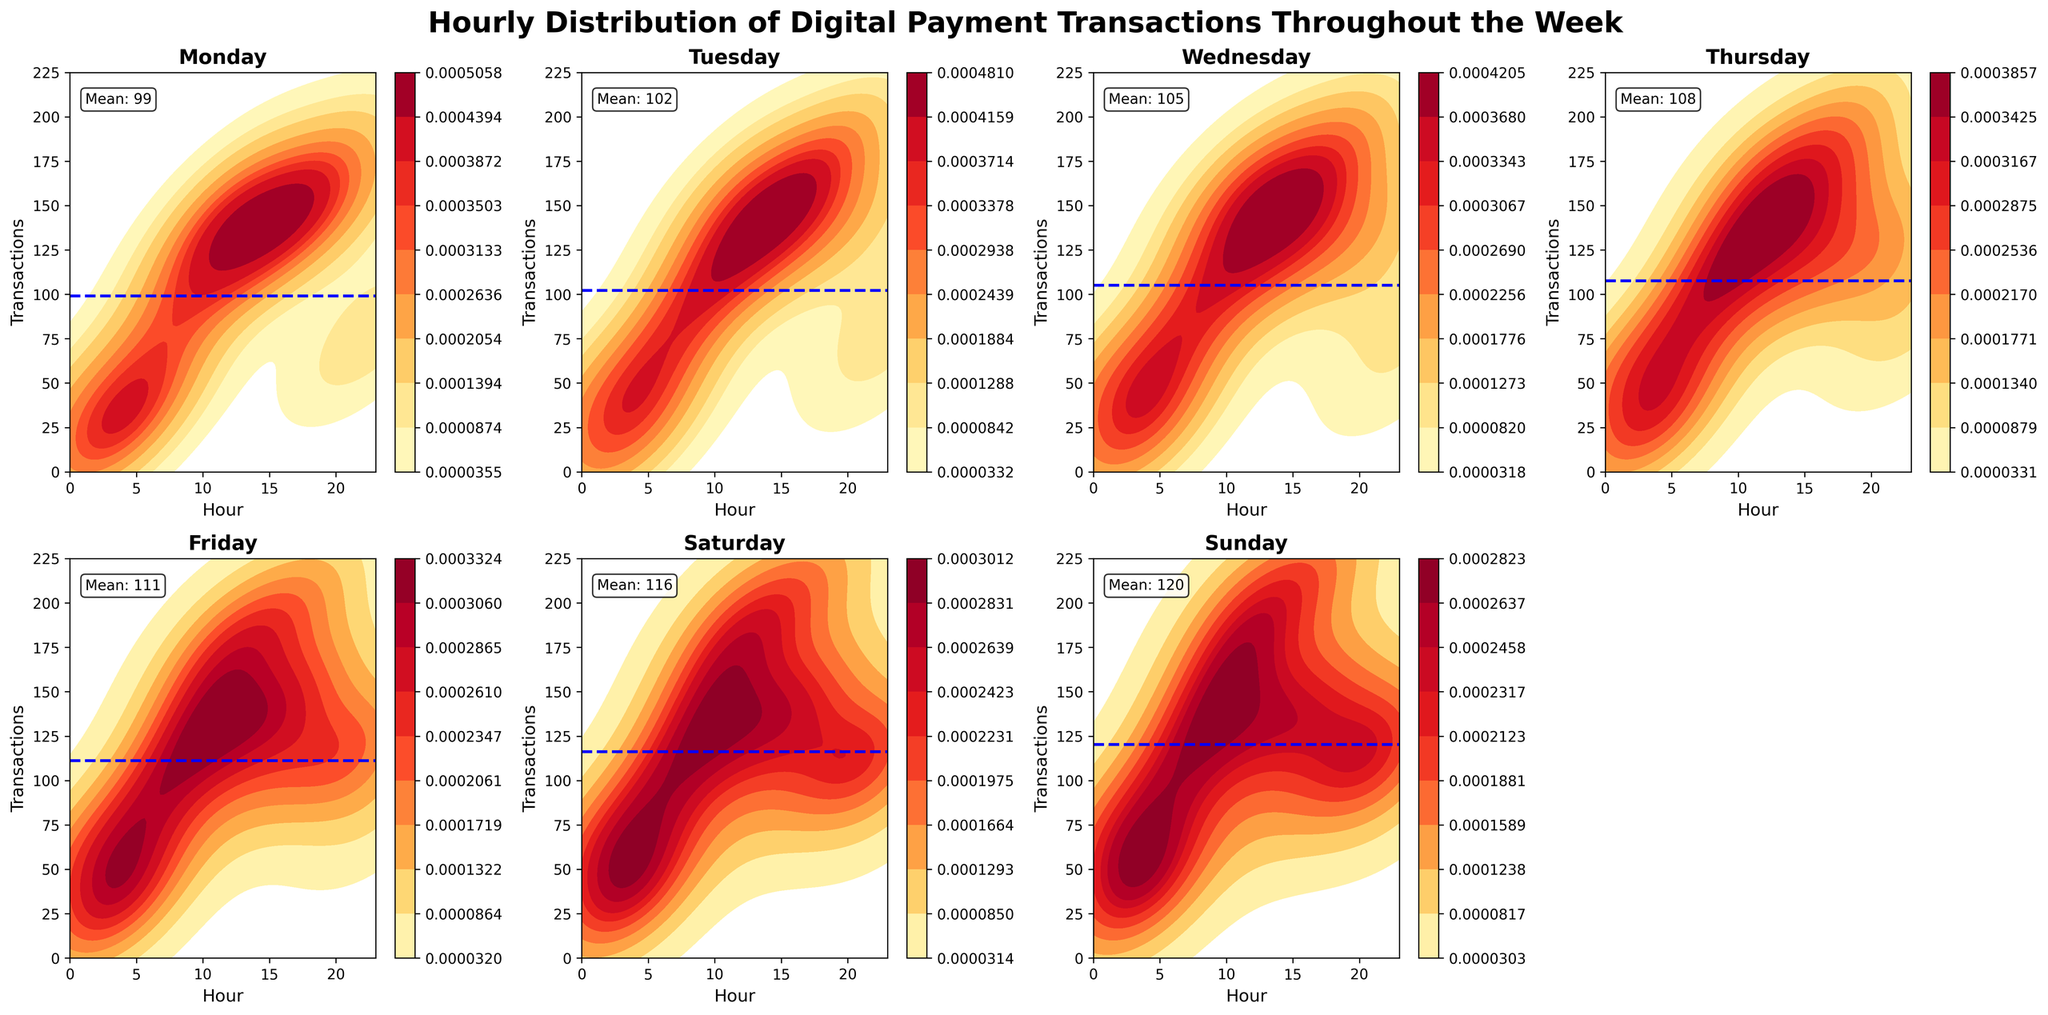What's the maximum number of transactions on Monday? Examine the Monday subplot and identify the highest value on the Transactions axis. This peak corresponds to the highest number of transactions.
Answer: 170 What is the overall trend of transactions from Monday to Sunday? Observing the density plots from Monday to Sunday, we notice that the frequency of high transaction counts generally increases towards the weekend, hitting peaks on Friday and Saturday.
Answer: Increasing On which day is the variance in transactions the highest? To determine the day with the highest variance, note the spread and concentration of density in the subplots. Days with more spread out, diverse height of the density plot lines have higher variance. Saturday and Sunday show the highest density peaks and distribution.
Answer: Saturday How does the mean number of transactions on Wednesday compare to Friday? Locate the horizontal mean line for both Wednesday and Friday. Compare their positions on the Transactions axis. The mean on Wednesday is around 108 while on Friday, it's closer to 114.
Answer: Higher on Friday Which day has the most frequent high transaction counts during the later hours (17:00-23:00)? Focus on the density distribution in each subplot during hours 17:00 to 23:00. Friday and Saturday show prominent density in this range, indicating more frequent high transaction counts.
Answer: Saturday What time of day generally has the lowest transaction counts across all days? Review each subplot and find the time span with the lowest density across all subplots. The early morning hours, around 3:00 to 5:00, show consistently low transaction densities.
Answer: 03:00-05:00 Compare the transaction pattern on Mondays and Sundays. How do they differ? Compare the subplots for Monday and Sunday. While both have lower transaction counts early on, Sunday shows a significant increase in transactions after noon, peaking higher and more consistently than Monday, particularly in the late hours.
Answer: Sunday shows higher variance and later peaks compared to Monday What is the payment method with the highest transaction count on average? Although not directly shown in the density plots, the majority of high transaction peaks, particularly on days with spikes, are driven by methods such as Credit Card and Digital Wallet.
Answer: Digital Wallet On which day and hour do we see the highest peak in transactions? Examine all subplots for the highest peak at any hour. The subplot for Sunday at hour 17:00 shows the highest peak in transactions.
Answer: Sunday at 17:00 How do transaction densities on weekdays compare to weekends? By examining the density plots for Monday to Friday (weekdays) and comparing them with Saturday and Sunday (weekends), we see that weekends have higher transaction densities overall, particularly later in the day.
Answer: Weekends show higher transaction densities 